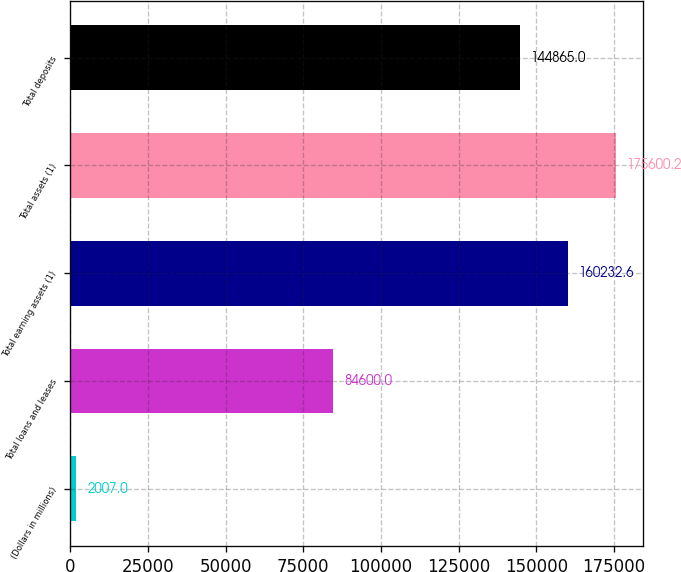Convert chart to OTSL. <chart><loc_0><loc_0><loc_500><loc_500><bar_chart><fcel>(Dollars in millions)<fcel>Total loans and leases<fcel>Total earning assets (1)<fcel>Total assets (1)<fcel>Total deposits<nl><fcel>2007<fcel>84600<fcel>160233<fcel>175600<fcel>144865<nl></chart> 